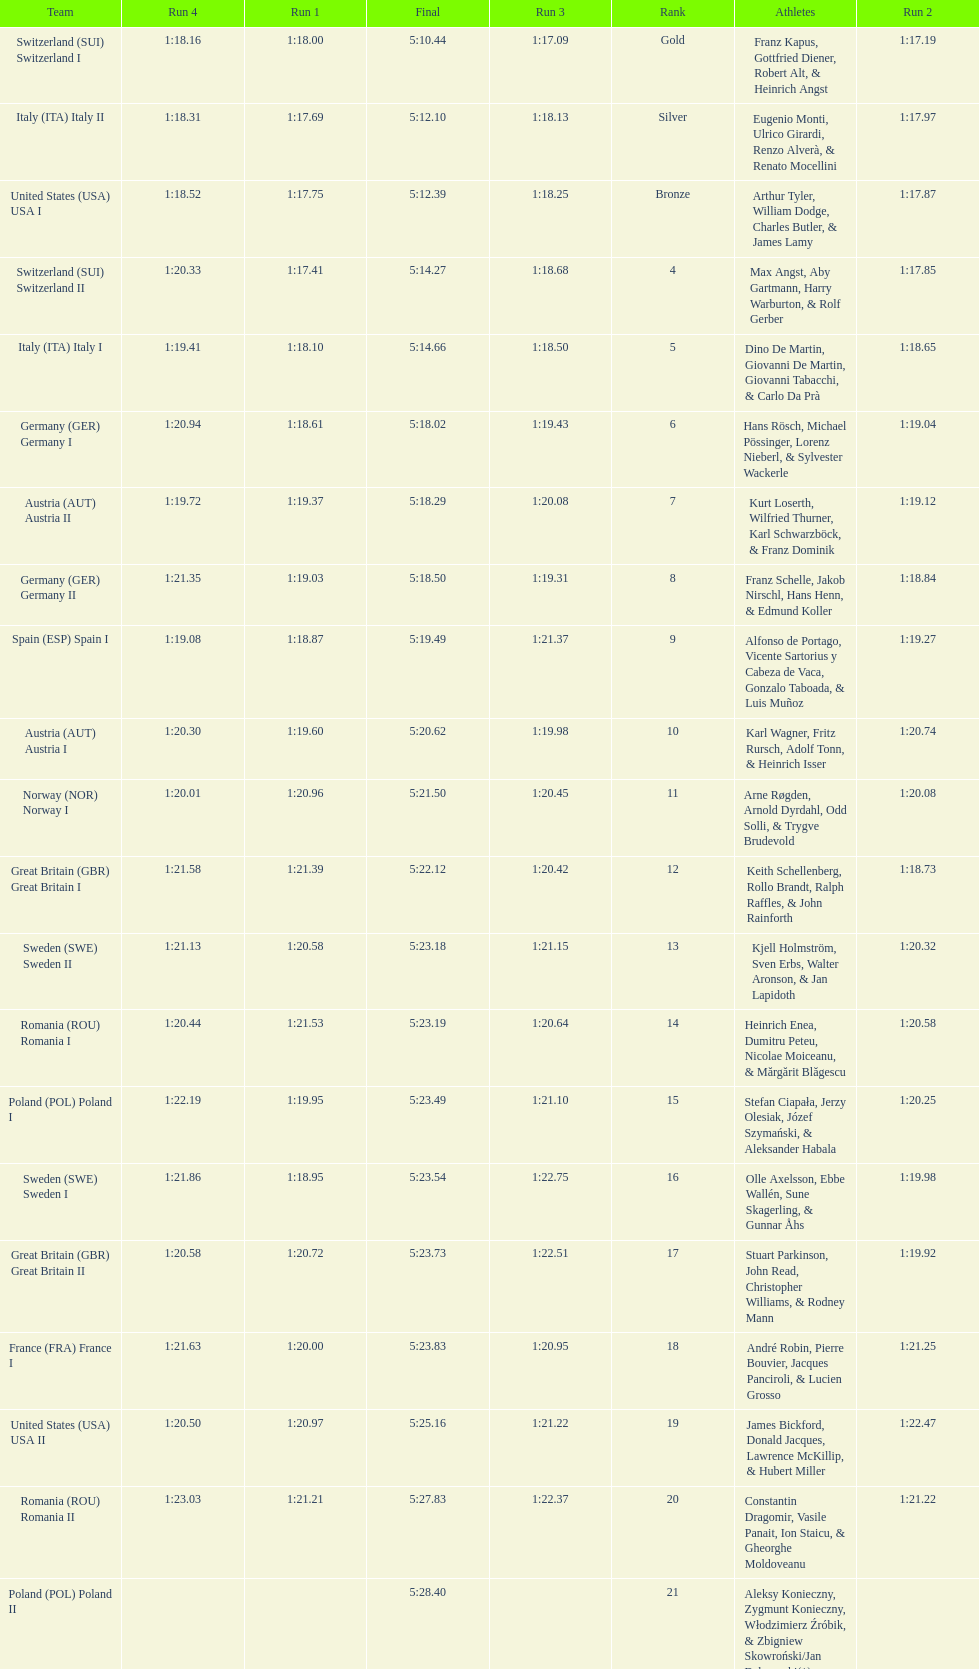What team comes after italy (ita) italy i? Germany I. 